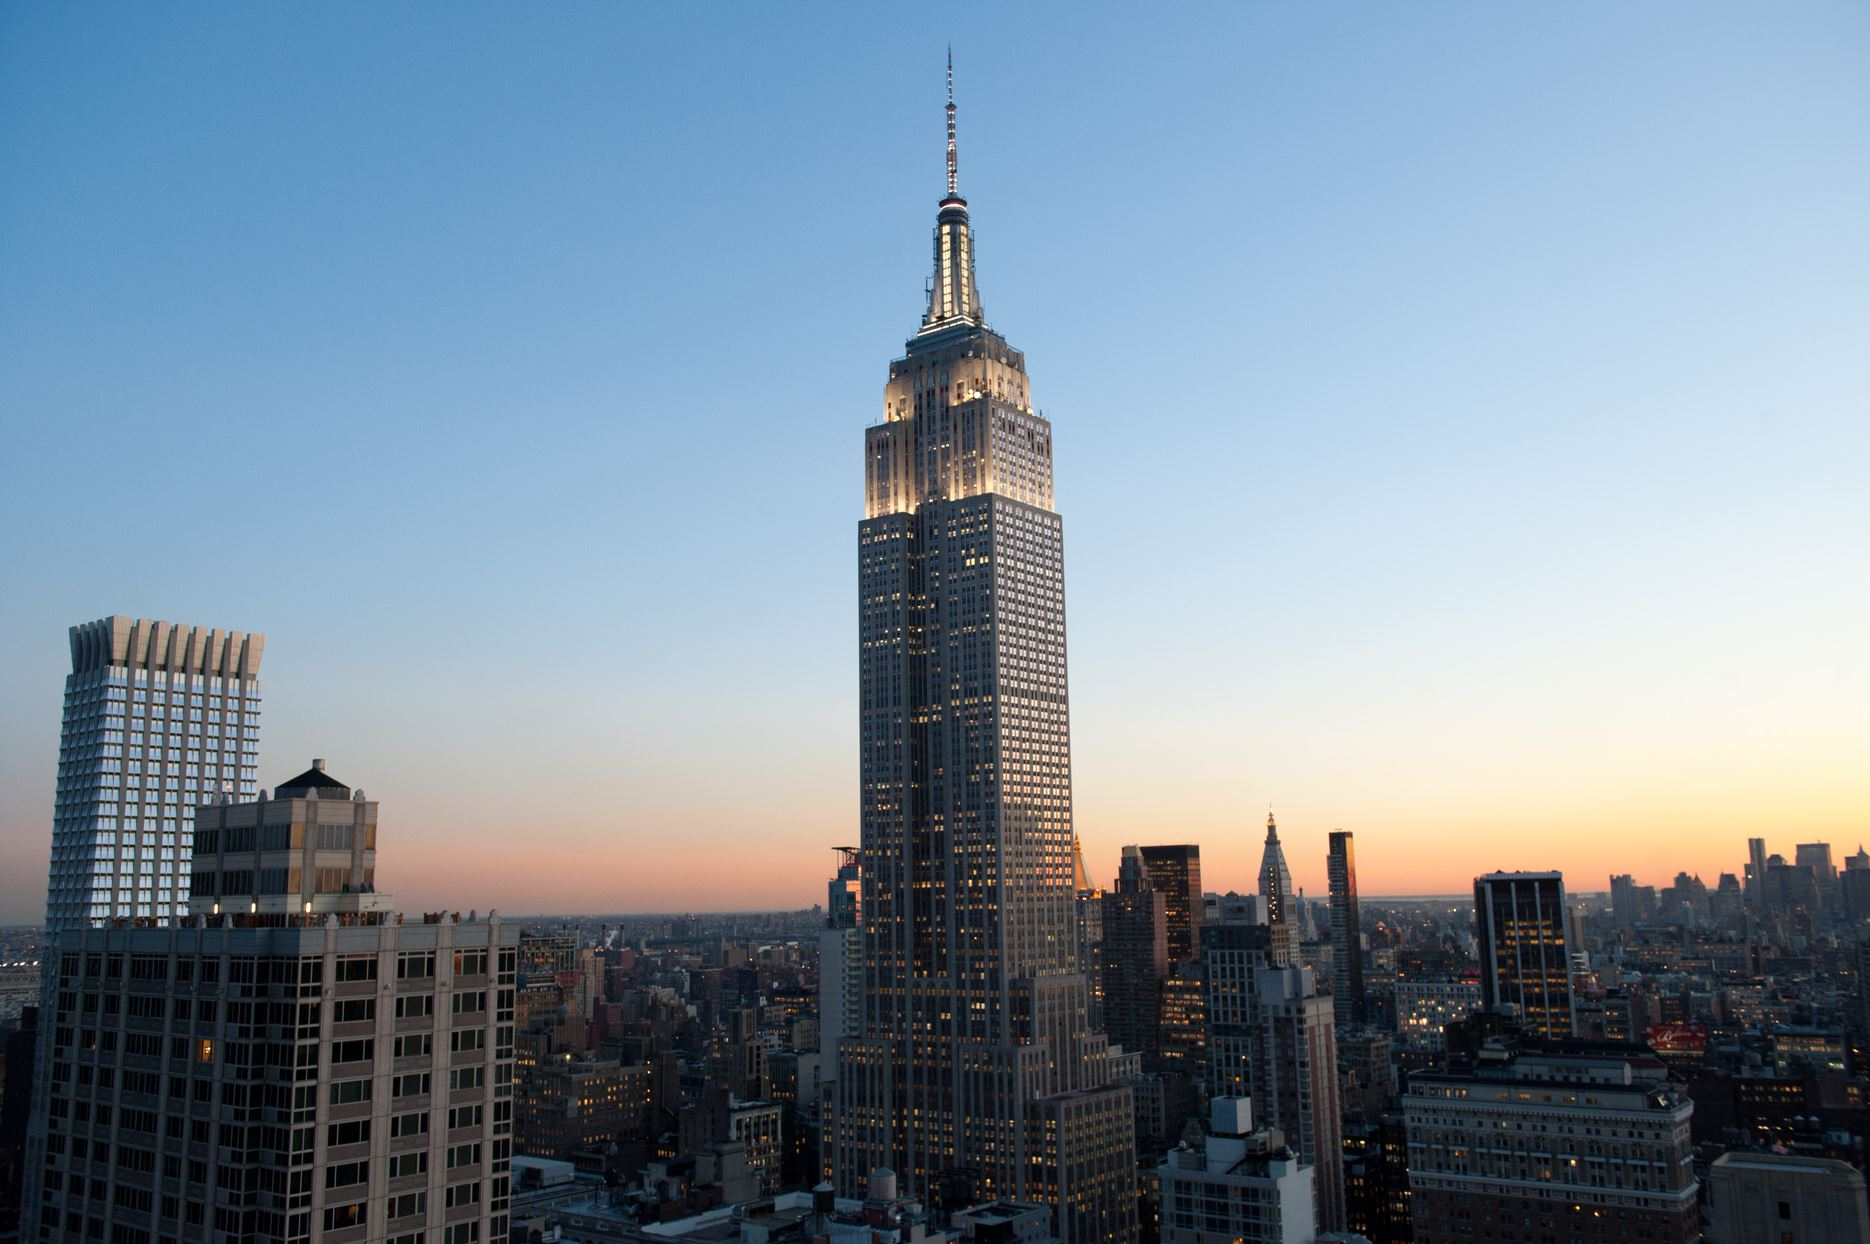Can you describe the colors and mood of the sky in the image? The sky in the image presents a stunning palette of colors, transitioning from a warm orange near the horizon to a cool blue as it extends upwards, suggesting a serene yet vibrant atmosphere typical of a city at sunset. This color gradient adds a tranquil yet dynamic backdrop to the urban landscape. 